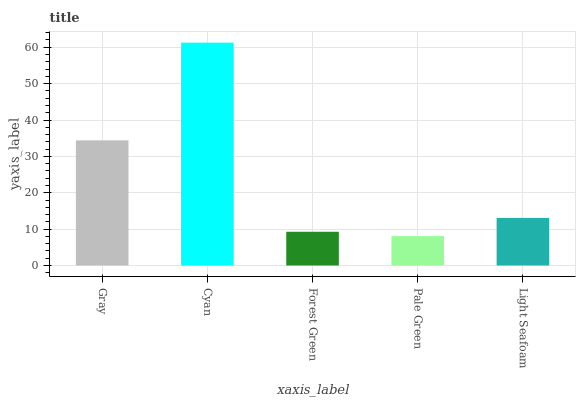Is Pale Green the minimum?
Answer yes or no. Yes. Is Cyan the maximum?
Answer yes or no. Yes. Is Forest Green the minimum?
Answer yes or no. No. Is Forest Green the maximum?
Answer yes or no. No. Is Cyan greater than Forest Green?
Answer yes or no. Yes. Is Forest Green less than Cyan?
Answer yes or no. Yes. Is Forest Green greater than Cyan?
Answer yes or no. No. Is Cyan less than Forest Green?
Answer yes or no. No. Is Light Seafoam the high median?
Answer yes or no. Yes. Is Light Seafoam the low median?
Answer yes or no. Yes. Is Gray the high median?
Answer yes or no. No. Is Pale Green the low median?
Answer yes or no. No. 